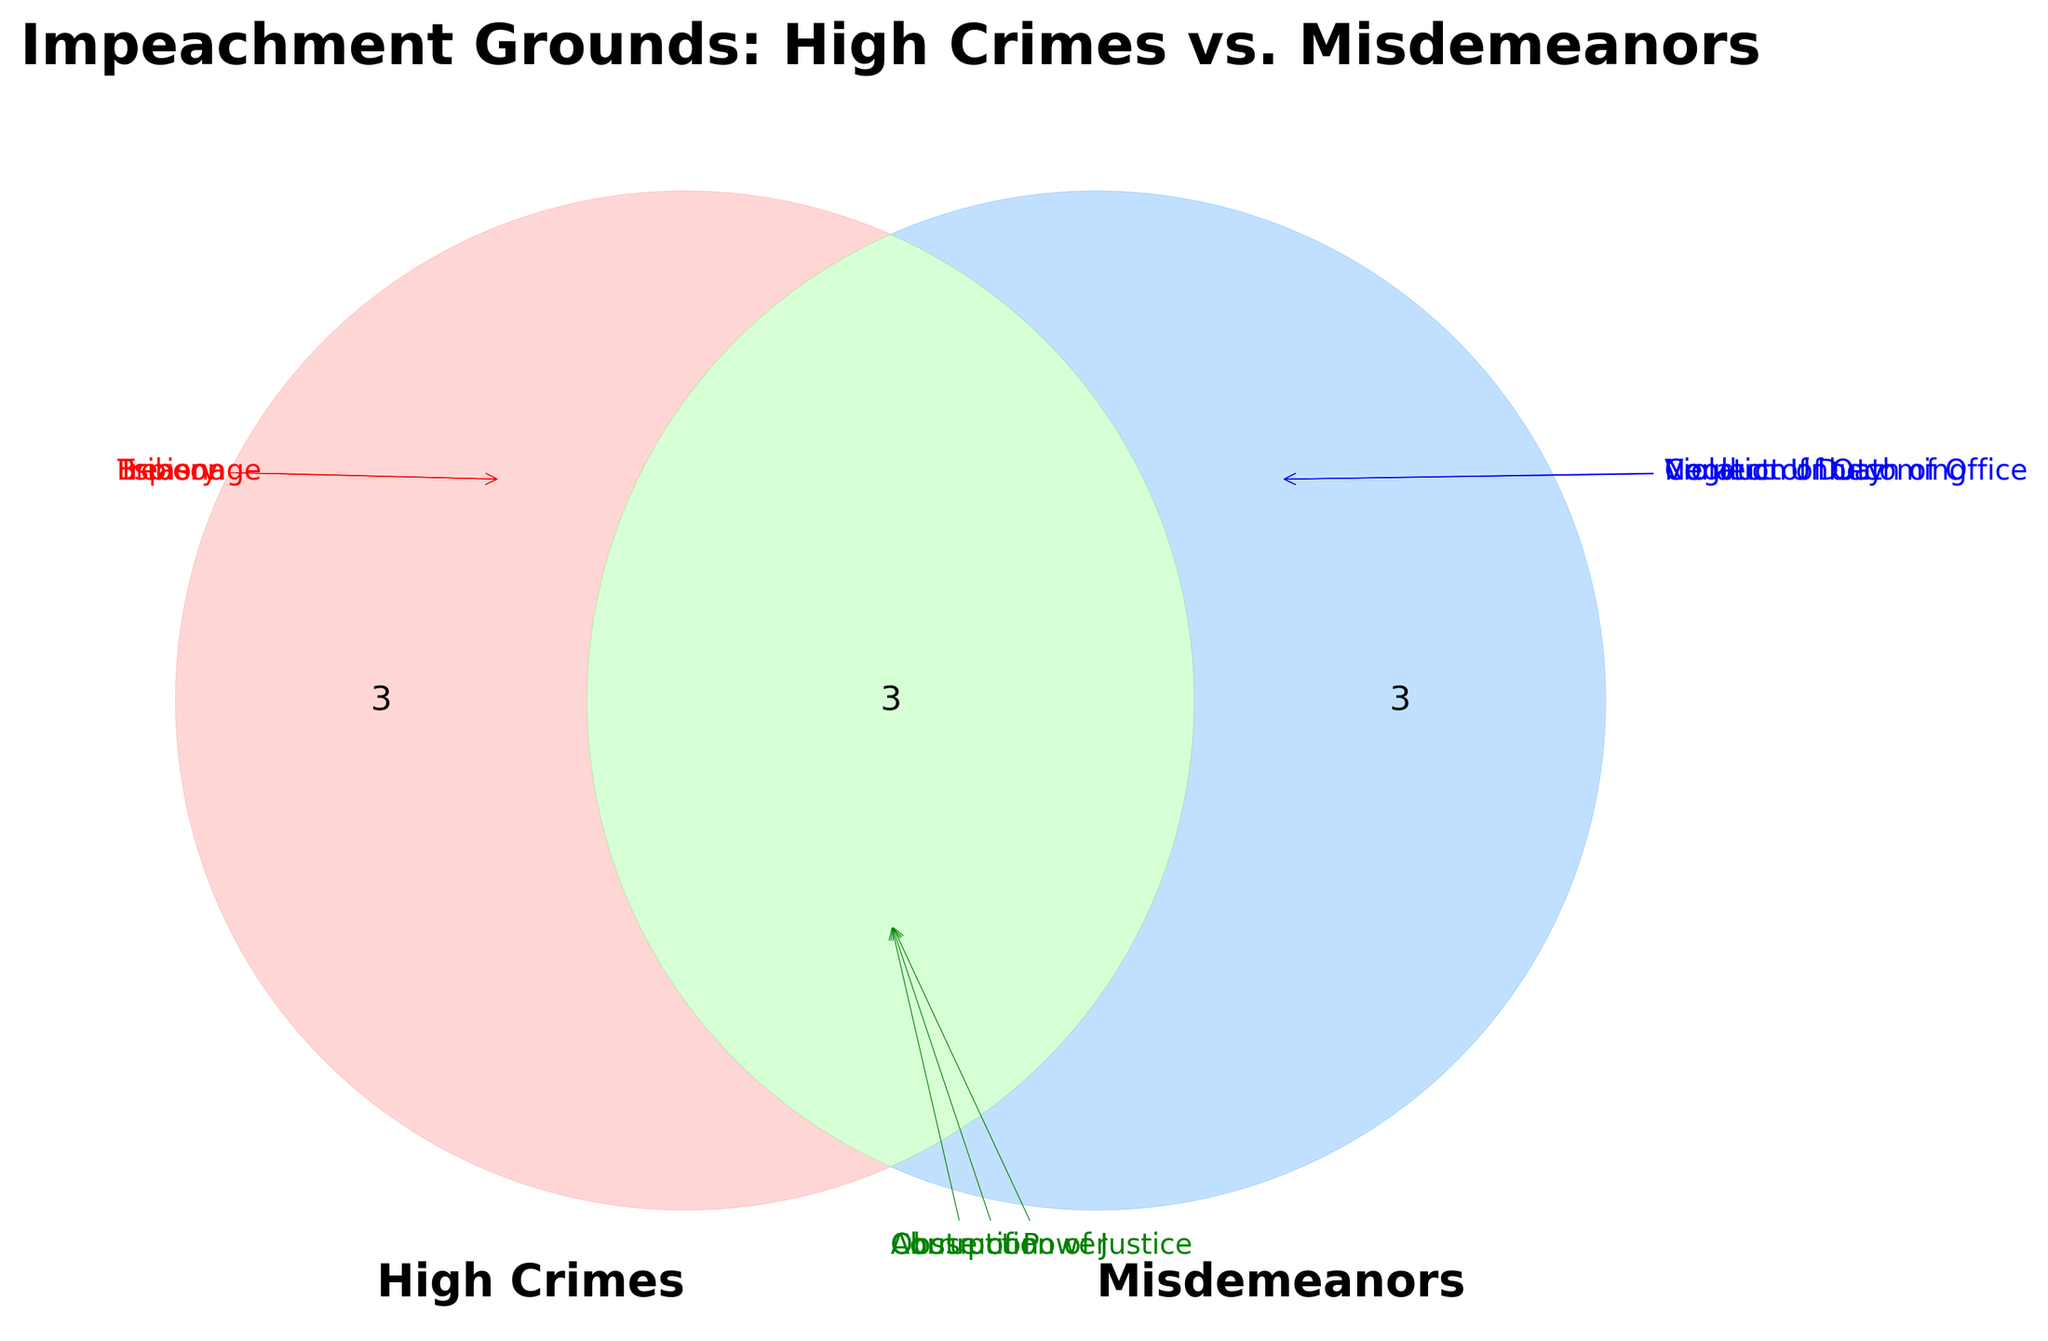What's the title of the figure? The title of the figure is displayed at the top, reading "Impeachment Grounds: High Crimes vs. Misdemeanors"
Answer: Impeachment Grounds: High Crimes vs. Misdemeanors Which item is common to both high crimes and misdemeanors? The overlapping section of the Venn Diagram lists items common to both categories, such as "Abuse of Power," "Obstruction of Justice," and "Corruption"
Answer: Abuse of Power, Obstruction of Justice, Corruption How many unique items are listed under misdemeanors only? Items that fall exclusively under misdemeanors are found in the right circle but outside the shared overlap. These items are "Violation of Oath of Office," "Neglect of Duty," and "Conduct Unbecoming". Counting these items gives three
Answer: 3 Which items are categorized as high crimes but not misdemeanors? Items solely within the high crimes circle but outside the intersection include "Treason," "Bribery," and "Espionage"
Answer: Treason, Bribery, Espionage Are there more unique items in high crimes than in misdemeanors? By counting the unique items in each category, high crimes have "Treason," "Bribery," and "Espionage" (3 items), while misdemeanors have "Violation of Oath of Office," "Neglect of Duty," and "Conduct Unbecoming" (3 items). Both categories have the same count
Answer: No Which item could be associated with misuse of government authority? Misuse of government authority often implies obstruction or corruption. Referring to the Venn Diagram, items like "Abuse of Power," "Obstruction of Justice," and "Corruption" fit this context. There is no single detailed characterization in the diagram, but these items broadly address governmental power misuse
Answer: Abuse of Power, Obstruction of Justice, Corruption 